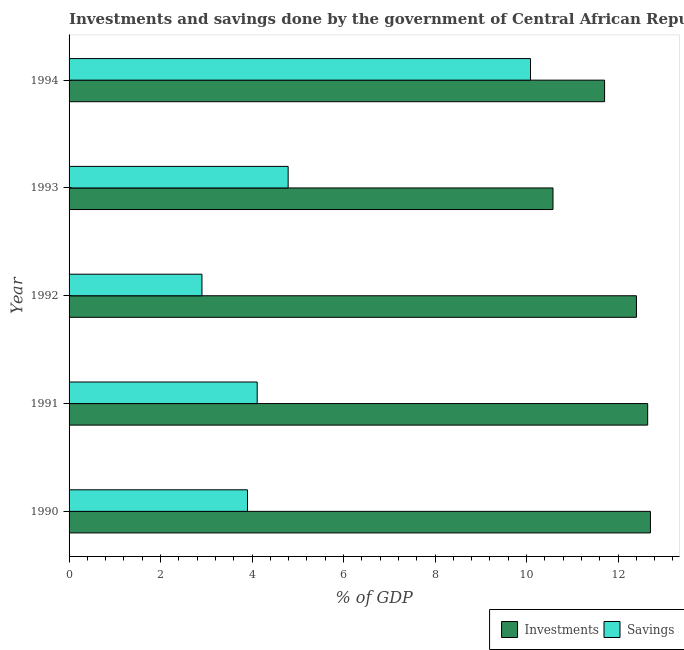How many different coloured bars are there?
Ensure brevity in your answer.  2. How many groups of bars are there?
Your answer should be very brief. 5. How many bars are there on the 4th tick from the top?
Offer a very short reply. 2. In how many cases, is the number of bars for a given year not equal to the number of legend labels?
Your answer should be very brief. 0. What is the investments of government in 1992?
Your response must be concise. 12.4. Across all years, what is the maximum savings of government?
Ensure brevity in your answer.  10.09. Across all years, what is the minimum savings of government?
Give a very brief answer. 2.9. In which year was the investments of government maximum?
Your answer should be compact. 1990. What is the total savings of government in the graph?
Offer a very short reply. 25.79. What is the difference between the savings of government in 1991 and that in 1993?
Your answer should be very brief. -0.68. What is the difference between the savings of government in 1990 and the investments of government in 1994?
Your answer should be compact. -7.81. What is the average investments of government per year?
Provide a succinct answer. 12.01. In the year 1990, what is the difference between the investments of government and savings of government?
Make the answer very short. 8.81. In how many years, is the investments of government greater than 7.2 %?
Your answer should be compact. 5. What is the ratio of the investments of government in 1991 to that in 1993?
Make the answer very short. 1.2. What is the difference between the highest and the second highest savings of government?
Ensure brevity in your answer.  5.3. What is the difference between the highest and the lowest savings of government?
Ensure brevity in your answer.  7.18. In how many years, is the savings of government greater than the average savings of government taken over all years?
Offer a very short reply. 1. What does the 2nd bar from the top in 1994 represents?
Ensure brevity in your answer.  Investments. What does the 1st bar from the bottom in 1991 represents?
Ensure brevity in your answer.  Investments. How many bars are there?
Keep it short and to the point. 10. What is the difference between two consecutive major ticks on the X-axis?
Your answer should be very brief. 2. Are the values on the major ticks of X-axis written in scientific E-notation?
Your response must be concise. No. Does the graph contain grids?
Make the answer very short. No. How are the legend labels stacked?
Offer a very short reply. Horizontal. What is the title of the graph?
Offer a terse response. Investments and savings done by the government of Central African Republic. Does "Foreign Liabilities" appear as one of the legend labels in the graph?
Your answer should be very brief. No. What is the label or title of the X-axis?
Provide a short and direct response. % of GDP. What is the % of GDP in Investments in 1990?
Keep it short and to the point. 12.71. What is the % of GDP in Savings in 1990?
Your answer should be compact. 3.9. What is the % of GDP of Investments in 1991?
Your answer should be very brief. 12.65. What is the % of GDP in Savings in 1991?
Your response must be concise. 4.11. What is the % of GDP of Investments in 1992?
Offer a very short reply. 12.4. What is the % of GDP of Savings in 1992?
Offer a terse response. 2.9. What is the % of GDP of Investments in 1993?
Your response must be concise. 10.58. What is the % of GDP in Savings in 1993?
Offer a terse response. 4.79. What is the % of GDP of Investments in 1994?
Provide a succinct answer. 11.71. What is the % of GDP of Savings in 1994?
Offer a very short reply. 10.09. Across all years, what is the maximum % of GDP of Investments?
Your answer should be very brief. 12.71. Across all years, what is the maximum % of GDP of Savings?
Offer a terse response. 10.09. Across all years, what is the minimum % of GDP in Investments?
Provide a short and direct response. 10.58. Across all years, what is the minimum % of GDP of Savings?
Your answer should be very brief. 2.9. What is the total % of GDP in Investments in the graph?
Your answer should be very brief. 60.04. What is the total % of GDP of Savings in the graph?
Offer a very short reply. 25.79. What is the difference between the % of GDP of Savings in 1990 and that in 1991?
Your answer should be compact. -0.21. What is the difference between the % of GDP of Investments in 1990 and that in 1992?
Your answer should be compact. 0.31. What is the difference between the % of GDP of Savings in 1990 and that in 1992?
Offer a terse response. 1. What is the difference between the % of GDP of Investments in 1990 and that in 1993?
Your answer should be very brief. 2.13. What is the difference between the % of GDP in Savings in 1990 and that in 1993?
Offer a terse response. -0.89. What is the difference between the % of GDP in Savings in 1990 and that in 1994?
Your response must be concise. -6.19. What is the difference between the % of GDP of Investments in 1991 and that in 1992?
Give a very brief answer. 0.25. What is the difference between the % of GDP in Savings in 1991 and that in 1992?
Your answer should be compact. 1.21. What is the difference between the % of GDP of Investments in 1991 and that in 1993?
Your response must be concise. 2.07. What is the difference between the % of GDP of Savings in 1991 and that in 1993?
Your response must be concise. -0.68. What is the difference between the % of GDP of Investments in 1991 and that in 1994?
Your response must be concise. 0.94. What is the difference between the % of GDP in Savings in 1991 and that in 1994?
Offer a terse response. -5.97. What is the difference between the % of GDP of Investments in 1992 and that in 1993?
Your answer should be compact. 1.82. What is the difference between the % of GDP in Savings in 1992 and that in 1993?
Provide a short and direct response. -1.88. What is the difference between the % of GDP of Investments in 1992 and that in 1994?
Ensure brevity in your answer.  0.7. What is the difference between the % of GDP of Savings in 1992 and that in 1994?
Offer a terse response. -7.18. What is the difference between the % of GDP of Investments in 1993 and that in 1994?
Give a very brief answer. -1.13. What is the difference between the % of GDP of Savings in 1993 and that in 1994?
Keep it short and to the point. -5.3. What is the difference between the % of GDP of Investments in 1990 and the % of GDP of Savings in 1991?
Offer a terse response. 8.6. What is the difference between the % of GDP of Investments in 1990 and the % of GDP of Savings in 1992?
Your response must be concise. 9.8. What is the difference between the % of GDP in Investments in 1990 and the % of GDP in Savings in 1993?
Keep it short and to the point. 7.92. What is the difference between the % of GDP of Investments in 1990 and the % of GDP of Savings in 1994?
Offer a very short reply. 2.62. What is the difference between the % of GDP in Investments in 1991 and the % of GDP in Savings in 1992?
Provide a short and direct response. 9.74. What is the difference between the % of GDP in Investments in 1991 and the % of GDP in Savings in 1993?
Your answer should be very brief. 7.86. What is the difference between the % of GDP in Investments in 1991 and the % of GDP in Savings in 1994?
Provide a short and direct response. 2.56. What is the difference between the % of GDP in Investments in 1992 and the % of GDP in Savings in 1993?
Your response must be concise. 7.61. What is the difference between the % of GDP of Investments in 1992 and the % of GDP of Savings in 1994?
Give a very brief answer. 2.32. What is the difference between the % of GDP in Investments in 1993 and the % of GDP in Savings in 1994?
Offer a terse response. 0.49. What is the average % of GDP in Investments per year?
Ensure brevity in your answer.  12.01. What is the average % of GDP in Savings per year?
Your answer should be compact. 5.16. In the year 1990, what is the difference between the % of GDP of Investments and % of GDP of Savings?
Provide a short and direct response. 8.81. In the year 1991, what is the difference between the % of GDP of Investments and % of GDP of Savings?
Your response must be concise. 8.54. In the year 1992, what is the difference between the % of GDP in Investments and % of GDP in Savings?
Make the answer very short. 9.5. In the year 1993, what is the difference between the % of GDP of Investments and % of GDP of Savings?
Make the answer very short. 5.79. In the year 1994, what is the difference between the % of GDP of Investments and % of GDP of Savings?
Your answer should be compact. 1.62. What is the ratio of the % of GDP in Investments in 1990 to that in 1991?
Your answer should be compact. 1. What is the ratio of the % of GDP of Savings in 1990 to that in 1991?
Give a very brief answer. 0.95. What is the ratio of the % of GDP of Investments in 1990 to that in 1992?
Make the answer very short. 1.02. What is the ratio of the % of GDP in Savings in 1990 to that in 1992?
Provide a short and direct response. 1.34. What is the ratio of the % of GDP of Investments in 1990 to that in 1993?
Give a very brief answer. 1.2. What is the ratio of the % of GDP in Savings in 1990 to that in 1993?
Offer a terse response. 0.81. What is the ratio of the % of GDP in Investments in 1990 to that in 1994?
Your response must be concise. 1.09. What is the ratio of the % of GDP in Savings in 1990 to that in 1994?
Keep it short and to the point. 0.39. What is the ratio of the % of GDP in Investments in 1991 to that in 1992?
Provide a succinct answer. 1.02. What is the ratio of the % of GDP in Savings in 1991 to that in 1992?
Give a very brief answer. 1.42. What is the ratio of the % of GDP of Investments in 1991 to that in 1993?
Your answer should be compact. 1.2. What is the ratio of the % of GDP of Savings in 1991 to that in 1993?
Provide a succinct answer. 0.86. What is the ratio of the % of GDP in Investments in 1991 to that in 1994?
Ensure brevity in your answer.  1.08. What is the ratio of the % of GDP in Savings in 1991 to that in 1994?
Offer a very short reply. 0.41. What is the ratio of the % of GDP of Investments in 1992 to that in 1993?
Your answer should be very brief. 1.17. What is the ratio of the % of GDP of Savings in 1992 to that in 1993?
Your response must be concise. 0.61. What is the ratio of the % of GDP in Investments in 1992 to that in 1994?
Provide a short and direct response. 1.06. What is the ratio of the % of GDP of Savings in 1992 to that in 1994?
Keep it short and to the point. 0.29. What is the ratio of the % of GDP of Investments in 1993 to that in 1994?
Offer a very short reply. 0.9. What is the ratio of the % of GDP of Savings in 1993 to that in 1994?
Provide a short and direct response. 0.47. What is the difference between the highest and the second highest % of GDP of Savings?
Your response must be concise. 5.3. What is the difference between the highest and the lowest % of GDP in Investments?
Your response must be concise. 2.13. What is the difference between the highest and the lowest % of GDP in Savings?
Offer a terse response. 7.18. 